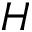Convert formula to latex. <formula><loc_0><loc_0><loc_500><loc_500>H</formula> 